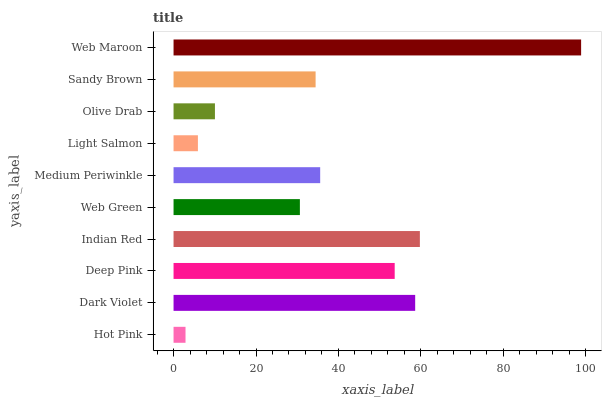Is Hot Pink the minimum?
Answer yes or no. Yes. Is Web Maroon the maximum?
Answer yes or no. Yes. Is Dark Violet the minimum?
Answer yes or no. No. Is Dark Violet the maximum?
Answer yes or no. No. Is Dark Violet greater than Hot Pink?
Answer yes or no. Yes. Is Hot Pink less than Dark Violet?
Answer yes or no. Yes. Is Hot Pink greater than Dark Violet?
Answer yes or no. No. Is Dark Violet less than Hot Pink?
Answer yes or no. No. Is Medium Periwinkle the high median?
Answer yes or no. Yes. Is Sandy Brown the low median?
Answer yes or no. Yes. Is Deep Pink the high median?
Answer yes or no. No. Is Light Salmon the low median?
Answer yes or no. No. 